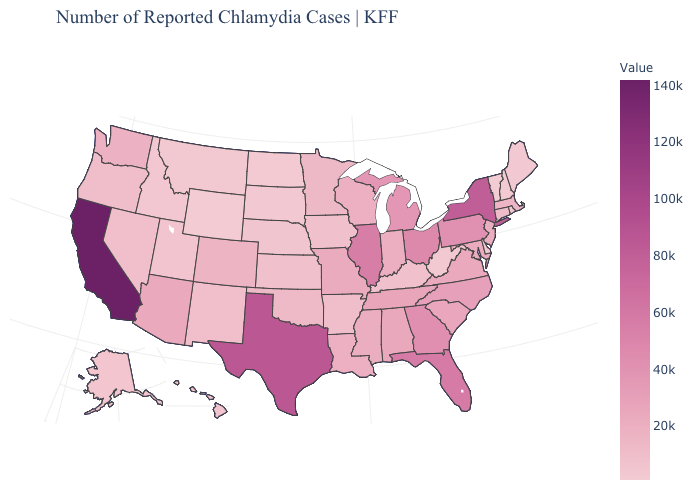Does North Dakota have the lowest value in the MidWest?
Write a very short answer. Yes. Does California have the highest value in the USA?
Short answer required. Yes. Among the states that border Mississippi , which have the lowest value?
Concise answer only. Arkansas. Does North Dakota have the lowest value in the MidWest?
Short answer required. Yes. Among the states that border Vermont , does Massachusetts have the lowest value?
Answer briefly. No. Among the states that border Delaware , which have the lowest value?
Quick response, please. New Jersey. Among the states that border Washington , does Oregon have the highest value?
Short answer required. Yes. 